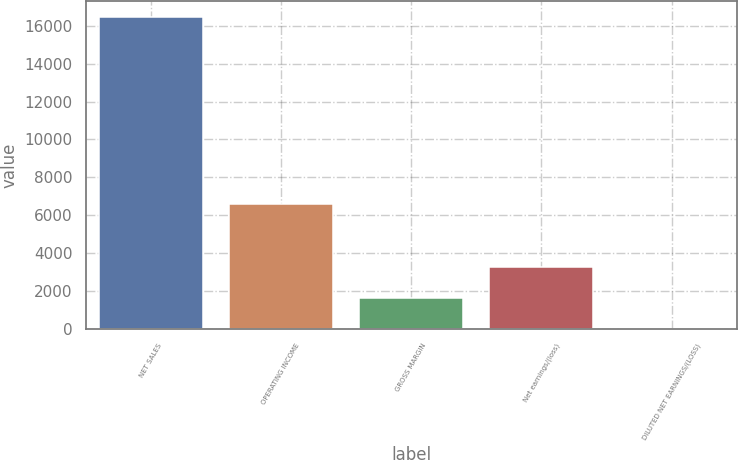Convert chart to OTSL. <chart><loc_0><loc_0><loc_500><loc_500><bar_chart><fcel>NET SALES<fcel>OPERATING INCOME<fcel>GROSS MARGIN<fcel>Net earnings/(loss)<fcel>DILUTED NET EARNINGS/(LOSS)<nl><fcel>16462<fcel>6585.44<fcel>1647.14<fcel>3293.24<fcel>1.04<nl></chart> 